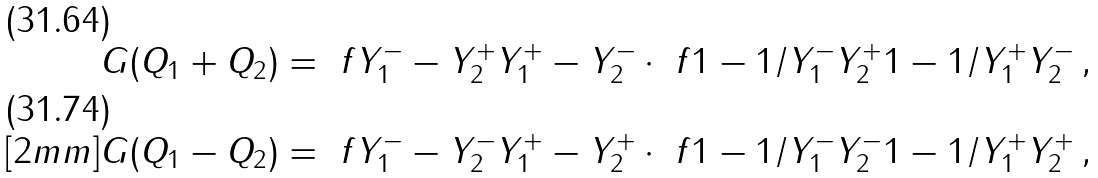Convert formula to latex. <formula><loc_0><loc_0><loc_500><loc_500>G ( Q _ { 1 } + Q _ { 2 } ) & = \ f { Y _ { 1 } ^ { - } - Y _ { 2 } ^ { + } } { Y _ { 1 } ^ { + } - Y _ { 2 } ^ { - } } \cdot \ f { 1 - 1 / Y _ { 1 } ^ { - } Y _ { 2 } ^ { + } } { 1 - 1 / Y _ { 1 } ^ { + } Y _ { 2 } ^ { - } } \, , \\ [ 2 m m ] G ( Q _ { 1 } - Q _ { 2 } ) & = \ f { Y _ { 1 } ^ { - } - Y _ { 2 } ^ { - } } { Y _ { 1 } ^ { + } - Y _ { 2 } ^ { + } } \cdot \ f { 1 - 1 / Y _ { 1 } ^ { - } Y _ { 2 } ^ { - } } { 1 - 1 / Y _ { 1 } ^ { + } Y _ { 2 } ^ { + } } \, ,</formula> 